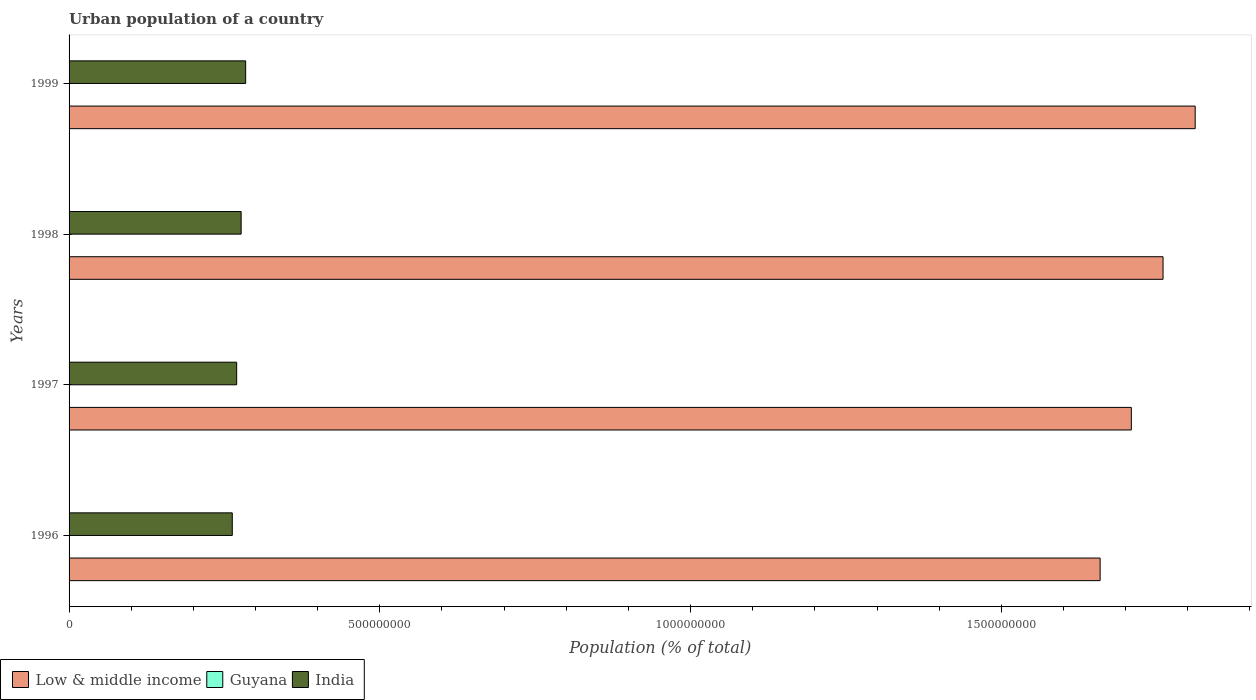How many different coloured bars are there?
Your response must be concise. 3. How many groups of bars are there?
Give a very brief answer. 4. Are the number of bars per tick equal to the number of legend labels?
Provide a succinct answer. Yes. How many bars are there on the 3rd tick from the top?
Your answer should be very brief. 3. What is the label of the 2nd group of bars from the top?
Offer a very short reply. 1998. What is the urban population in Low & middle income in 1999?
Provide a short and direct response. 1.81e+09. Across all years, what is the maximum urban population in Guyana?
Provide a short and direct response. 2.13e+05. Across all years, what is the minimum urban population in Guyana?
Provide a short and direct response. 2.12e+05. In which year was the urban population in India maximum?
Your answer should be very brief. 1999. What is the total urban population in Low & middle income in the graph?
Offer a very short reply. 6.94e+09. What is the difference between the urban population in Low & middle income in 1996 and that in 1998?
Give a very brief answer. -1.01e+08. What is the difference between the urban population in Low & middle income in 1996 and the urban population in India in 1998?
Your answer should be very brief. 1.38e+09. What is the average urban population in Low & middle income per year?
Your answer should be compact. 1.74e+09. In the year 1998, what is the difference between the urban population in Guyana and urban population in India?
Make the answer very short. -2.77e+08. What is the ratio of the urban population in India in 1998 to that in 1999?
Provide a succinct answer. 0.97. Is the difference between the urban population in Guyana in 1996 and 1997 greater than the difference between the urban population in India in 1996 and 1997?
Make the answer very short. Yes. What is the difference between the highest and the second highest urban population in Guyana?
Your response must be concise. 170. What is the difference between the highest and the lowest urban population in Guyana?
Provide a succinct answer. 935. In how many years, is the urban population in Low & middle income greater than the average urban population in Low & middle income taken over all years?
Give a very brief answer. 2. Is the sum of the urban population in India in 1997 and 1999 greater than the maximum urban population in Guyana across all years?
Your response must be concise. Yes. What does the 3rd bar from the top in 1999 represents?
Your answer should be compact. Low & middle income. What does the 2nd bar from the bottom in 1996 represents?
Your answer should be compact. Guyana. Is it the case that in every year, the sum of the urban population in Low & middle income and urban population in India is greater than the urban population in Guyana?
Your answer should be very brief. Yes. Are the values on the major ticks of X-axis written in scientific E-notation?
Provide a short and direct response. No. Does the graph contain any zero values?
Your response must be concise. No. Does the graph contain grids?
Provide a succinct answer. No. What is the title of the graph?
Make the answer very short. Urban population of a country. Does "Switzerland" appear as one of the legend labels in the graph?
Make the answer very short. No. What is the label or title of the X-axis?
Make the answer very short. Population (% of total). What is the label or title of the Y-axis?
Ensure brevity in your answer.  Years. What is the Population (% of total) of Low & middle income in 1996?
Ensure brevity in your answer.  1.66e+09. What is the Population (% of total) of Guyana in 1996?
Offer a very short reply. 2.12e+05. What is the Population (% of total) of India in 1996?
Ensure brevity in your answer.  2.63e+08. What is the Population (% of total) in Low & middle income in 1997?
Provide a succinct answer. 1.71e+09. What is the Population (% of total) in Guyana in 1997?
Give a very brief answer. 2.13e+05. What is the Population (% of total) of India in 1997?
Provide a succinct answer. 2.70e+08. What is the Population (% of total) of Low & middle income in 1998?
Ensure brevity in your answer.  1.76e+09. What is the Population (% of total) of Guyana in 1998?
Ensure brevity in your answer.  2.13e+05. What is the Population (% of total) of India in 1998?
Your answer should be very brief. 2.77e+08. What is the Population (% of total) in Low & middle income in 1999?
Make the answer very short. 1.81e+09. What is the Population (% of total) in Guyana in 1999?
Provide a short and direct response. 2.13e+05. What is the Population (% of total) in India in 1999?
Your answer should be very brief. 2.84e+08. Across all years, what is the maximum Population (% of total) in Low & middle income?
Offer a very short reply. 1.81e+09. Across all years, what is the maximum Population (% of total) in Guyana?
Keep it short and to the point. 2.13e+05. Across all years, what is the maximum Population (% of total) in India?
Your answer should be compact. 2.84e+08. Across all years, what is the minimum Population (% of total) of Low & middle income?
Your response must be concise. 1.66e+09. Across all years, what is the minimum Population (% of total) in Guyana?
Ensure brevity in your answer.  2.12e+05. Across all years, what is the minimum Population (% of total) in India?
Offer a very short reply. 2.63e+08. What is the total Population (% of total) in Low & middle income in the graph?
Provide a short and direct response. 6.94e+09. What is the total Population (% of total) in Guyana in the graph?
Offer a very short reply. 8.51e+05. What is the total Population (% of total) in India in the graph?
Provide a short and direct response. 1.09e+09. What is the difference between the Population (% of total) of Low & middle income in 1996 and that in 1997?
Your response must be concise. -5.02e+07. What is the difference between the Population (% of total) in Guyana in 1996 and that in 1997?
Give a very brief answer. -411. What is the difference between the Population (% of total) in India in 1996 and that in 1997?
Make the answer very short. -7.07e+06. What is the difference between the Population (% of total) of Low & middle income in 1996 and that in 1998?
Your answer should be compact. -1.01e+08. What is the difference between the Population (% of total) in Guyana in 1996 and that in 1998?
Keep it short and to the point. -765. What is the difference between the Population (% of total) of India in 1996 and that in 1998?
Your response must be concise. -1.43e+07. What is the difference between the Population (% of total) in Low & middle income in 1996 and that in 1999?
Your response must be concise. -1.53e+08. What is the difference between the Population (% of total) of Guyana in 1996 and that in 1999?
Keep it short and to the point. -935. What is the difference between the Population (% of total) of India in 1996 and that in 1999?
Your answer should be very brief. -2.15e+07. What is the difference between the Population (% of total) in Low & middle income in 1997 and that in 1998?
Your answer should be very brief. -5.11e+07. What is the difference between the Population (% of total) of Guyana in 1997 and that in 1998?
Your response must be concise. -354. What is the difference between the Population (% of total) in India in 1997 and that in 1998?
Your answer should be compact. -7.18e+06. What is the difference between the Population (% of total) of Low & middle income in 1997 and that in 1999?
Provide a short and direct response. -1.03e+08. What is the difference between the Population (% of total) of Guyana in 1997 and that in 1999?
Your answer should be very brief. -524. What is the difference between the Population (% of total) in India in 1997 and that in 1999?
Keep it short and to the point. -1.44e+07. What is the difference between the Population (% of total) of Low & middle income in 1998 and that in 1999?
Provide a short and direct response. -5.17e+07. What is the difference between the Population (% of total) of Guyana in 1998 and that in 1999?
Offer a very short reply. -170. What is the difference between the Population (% of total) in India in 1998 and that in 1999?
Your answer should be very brief. -7.26e+06. What is the difference between the Population (% of total) in Low & middle income in 1996 and the Population (% of total) in Guyana in 1997?
Your answer should be compact. 1.66e+09. What is the difference between the Population (% of total) of Low & middle income in 1996 and the Population (% of total) of India in 1997?
Give a very brief answer. 1.39e+09. What is the difference between the Population (% of total) in Guyana in 1996 and the Population (% of total) in India in 1997?
Make the answer very short. -2.69e+08. What is the difference between the Population (% of total) in Low & middle income in 1996 and the Population (% of total) in Guyana in 1998?
Your answer should be very brief. 1.66e+09. What is the difference between the Population (% of total) of Low & middle income in 1996 and the Population (% of total) of India in 1998?
Provide a succinct answer. 1.38e+09. What is the difference between the Population (% of total) of Guyana in 1996 and the Population (% of total) of India in 1998?
Offer a terse response. -2.77e+08. What is the difference between the Population (% of total) in Low & middle income in 1996 and the Population (% of total) in Guyana in 1999?
Provide a short and direct response. 1.66e+09. What is the difference between the Population (% of total) of Low & middle income in 1996 and the Population (% of total) of India in 1999?
Ensure brevity in your answer.  1.37e+09. What is the difference between the Population (% of total) of Guyana in 1996 and the Population (% of total) of India in 1999?
Offer a very short reply. -2.84e+08. What is the difference between the Population (% of total) of Low & middle income in 1997 and the Population (% of total) of Guyana in 1998?
Your answer should be very brief. 1.71e+09. What is the difference between the Population (% of total) in Low & middle income in 1997 and the Population (% of total) in India in 1998?
Provide a short and direct response. 1.43e+09. What is the difference between the Population (% of total) of Guyana in 1997 and the Population (% of total) of India in 1998?
Your response must be concise. -2.77e+08. What is the difference between the Population (% of total) of Low & middle income in 1997 and the Population (% of total) of Guyana in 1999?
Your response must be concise. 1.71e+09. What is the difference between the Population (% of total) in Low & middle income in 1997 and the Population (% of total) in India in 1999?
Provide a short and direct response. 1.43e+09. What is the difference between the Population (% of total) of Guyana in 1997 and the Population (% of total) of India in 1999?
Your answer should be compact. -2.84e+08. What is the difference between the Population (% of total) in Low & middle income in 1998 and the Population (% of total) in Guyana in 1999?
Ensure brevity in your answer.  1.76e+09. What is the difference between the Population (% of total) of Low & middle income in 1998 and the Population (% of total) of India in 1999?
Give a very brief answer. 1.48e+09. What is the difference between the Population (% of total) of Guyana in 1998 and the Population (% of total) of India in 1999?
Provide a succinct answer. -2.84e+08. What is the average Population (% of total) in Low & middle income per year?
Give a very brief answer. 1.74e+09. What is the average Population (% of total) in Guyana per year?
Your answer should be compact. 2.13e+05. What is the average Population (% of total) in India per year?
Make the answer very short. 2.73e+08. In the year 1996, what is the difference between the Population (% of total) of Low & middle income and Population (% of total) of Guyana?
Provide a succinct answer. 1.66e+09. In the year 1996, what is the difference between the Population (% of total) of Low & middle income and Population (% of total) of India?
Offer a terse response. 1.40e+09. In the year 1996, what is the difference between the Population (% of total) of Guyana and Population (% of total) of India?
Provide a short and direct response. -2.62e+08. In the year 1997, what is the difference between the Population (% of total) of Low & middle income and Population (% of total) of Guyana?
Offer a very short reply. 1.71e+09. In the year 1997, what is the difference between the Population (% of total) of Low & middle income and Population (% of total) of India?
Your response must be concise. 1.44e+09. In the year 1997, what is the difference between the Population (% of total) in Guyana and Population (% of total) in India?
Your answer should be compact. -2.69e+08. In the year 1998, what is the difference between the Population (% of total) of Low & middle income and Population (% of total) of Guyana?
Offer a very short reply. 1.76e+09. In the year 1998, what is the difference between the Population (% of total) of Low & middle income and Population (% of total) of India?
Make the answer very short. 1.48e+09. In the year 1998, what is the difference between the Population (% of total) of Guyana and Population (% of total) of India?
Give a very brief answer. -2.77e+08. In the year 1999, what is the difference between the Population (% of total) of Low & middle income and Population (% of total) of Guyana?
Your answer should be compact. 1.81e+09. In the year 1999, what is the difference between the Population (% of total) in Low & middle income and Population (% of total) in India?
Offer a very short reply. 1.53e+09. In the year 1999, what is the difference between the Population (% of total) of Guyana and Population (% of total) of India?
Provide a succinct answer. -2.84e+08. What is the ratio of the Population (% of total) of Low & middle income in 1996 to that in 1997?
Your answer should be compact. 0.97. What is the ratio of the Population (% of total) of Guyana in 1996 to that in 1997?
Provide a succinct answer. 1. What is the ratio of the Population (% of total) in India in 1996 to that in 1997?
Keep it short and to the point. 0.97. What is the ratio of the Population (% of total) in Low & middle income in 1996 to that in 1998?
Your response must be concise. 0.94. What is the ratio of the Population (% of total) in India in 1996 to that in 1998?
Your answer should be compact. 0.95. What is the ratio of the Population (% of total) in Low & middle income in 1996 to that in 1999?
Offer a terse response. 0.92. What is the ratio of the Population (% of total) of Guyana in 1996 to that in 1999?
Give a very brief answer. 1. What is the ratio of the Population (% of total) of India in 1996 to that in 1999?
Make the answer very short. 0.92. What is the ratio of the Population (% of total) in Low & middle income in 1997 to that in 1998?
Keep it short and to the point. 0.97. What is the ratio of the Population (% of total) of India in 1997 to that in 1998?
Offer a terse response. 0.97. What is the ratio of the Population (% of total) in Low & middle income in 1997 to that in 1999?
Ensure brevity in your answer.  0.94. What is the ratio of the Population (% of total) of Guyana in 1997 to that in 1999?
Give a very brief answer. 1. What is the ratio of the Population (% of total) of India in 1997 to that in 1999?
Provide a succinct answer. 0.95. What is the ratio of the Population (% of total) in Low & middle income in 1998 to that in 1999?
Give a very brief answer. 0.97. What is the ratio of the Population (% of total) of India in 1998 to that in 1999?
Keep it short and to the point. 0.97. What is the difference between the highest and the second highest Population (% of total) of Low & middle income?
Ensure brevity in your answer.  5.17e+07. What is the difference between the highest and the second highest Population (% of total) of Guyana?
Your answer should be very brief. 170. What is the difference between the highest and the second highest Population (% of total) of India?
Provide a succinct answer. 7.26e+06. What is the difference between the highest and the lowest Population (% of total) of Low & middle income?
Your answer should be very brief. 1.53e+08. What is the difference between the highest and the lowest Population (% of total) in Guyana?
Your answer should be compact. 935. What is the difference between the highest and the lowest Population (% of total) in India?
Keep it short and to the point. 2.15e+07. 